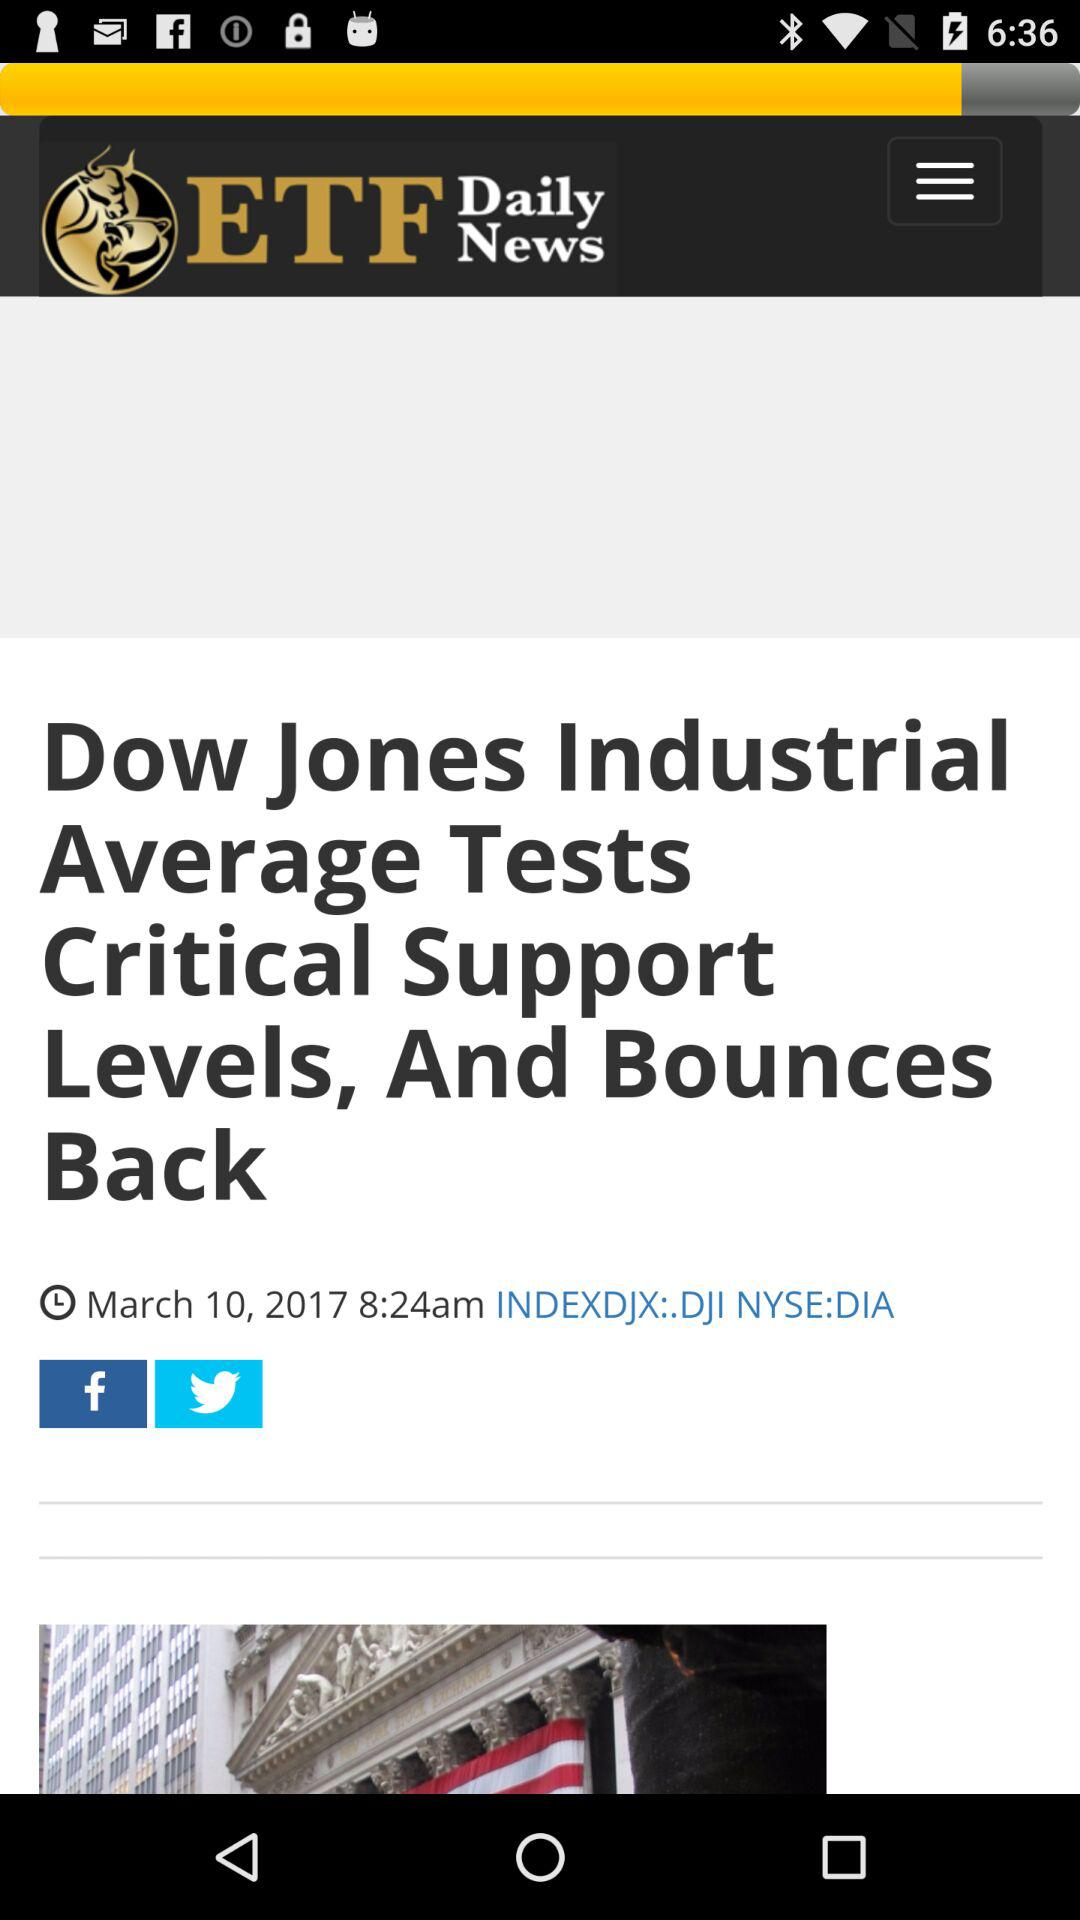What's the published date of this article? The published date of this article is March 10, 2017. 